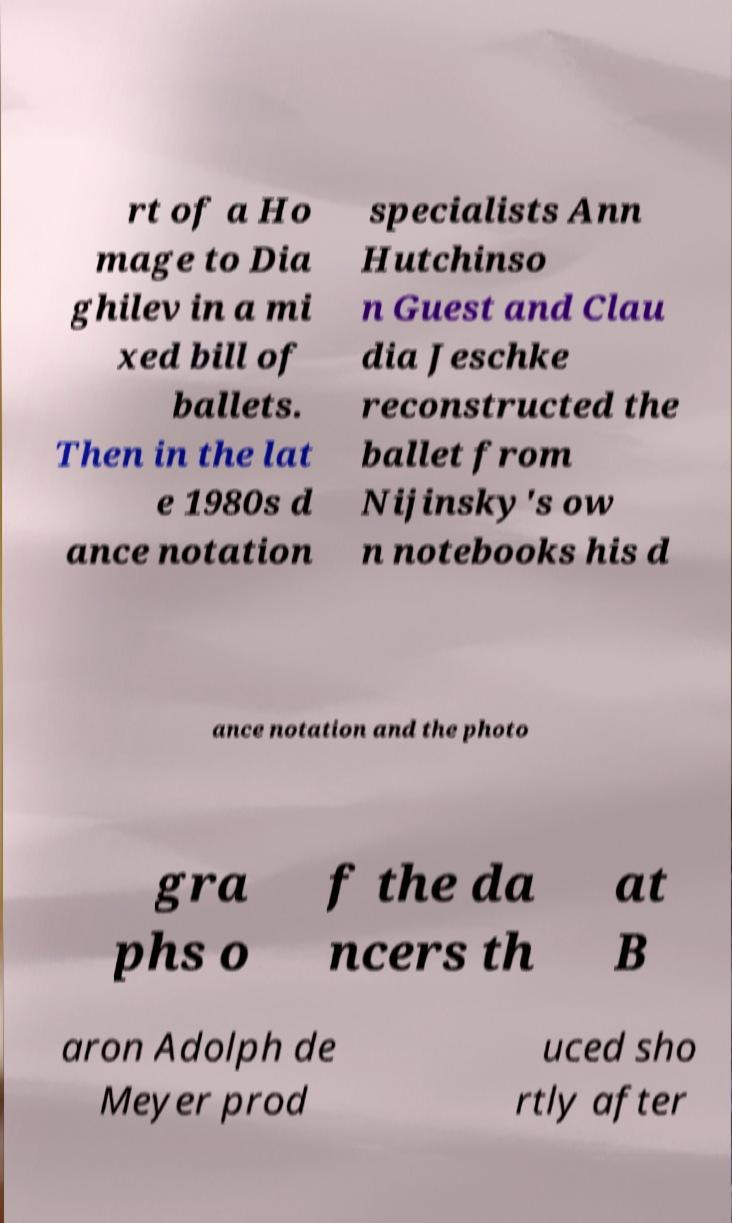Can you read and provide the text displayed in the image?This photo seems to have some interesting text. Can you extract and type it out for me? rt of a Ho mage to Dia ghilev in a mi xed bill of ballets. Then in the lat e 1980s d ance notation specialists Ann Hutchinso n Guest and Clau dia Jeschke reconstructed the ballet from Nijinsky's ow n notebooks his d ance notation and the photo gra phs o f the da ncers th at B aron Adolph de Meyer prod uced sho rtly after 